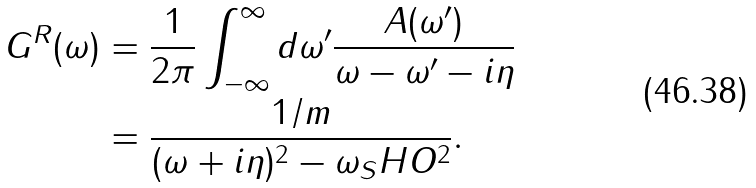Convert formula to latex. <formula><loc_0><loc_0><loc_500><loc_500>G ^ { R } ( \omega ) & = \frac { 1 } { 2 \pi } \int _ { - \infty } ^ { \infty } d \omega ^ { \prime } \frac { A ( \omega ^ { \prime } ) } { \omega - \omega ^ { \prime } - i \eta } \\ & = \frac { 1 / m } { ( \omega + i \eta ) ^ { 2 } - \omega _ { S } H O ^ { 2 } } .</formula> 